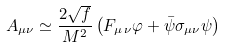<formula> <loc_0><loc_0><loc_500><loc_500>A _ { \mu \nu } \simeq \frac { 2 \sqrt { f } } { M ^ { 2 } } \left ( F _ { \mu \, \nu } \varphi + \bar { \psi } \sigma _ { \mu \nu } \psi \right )</formula> 